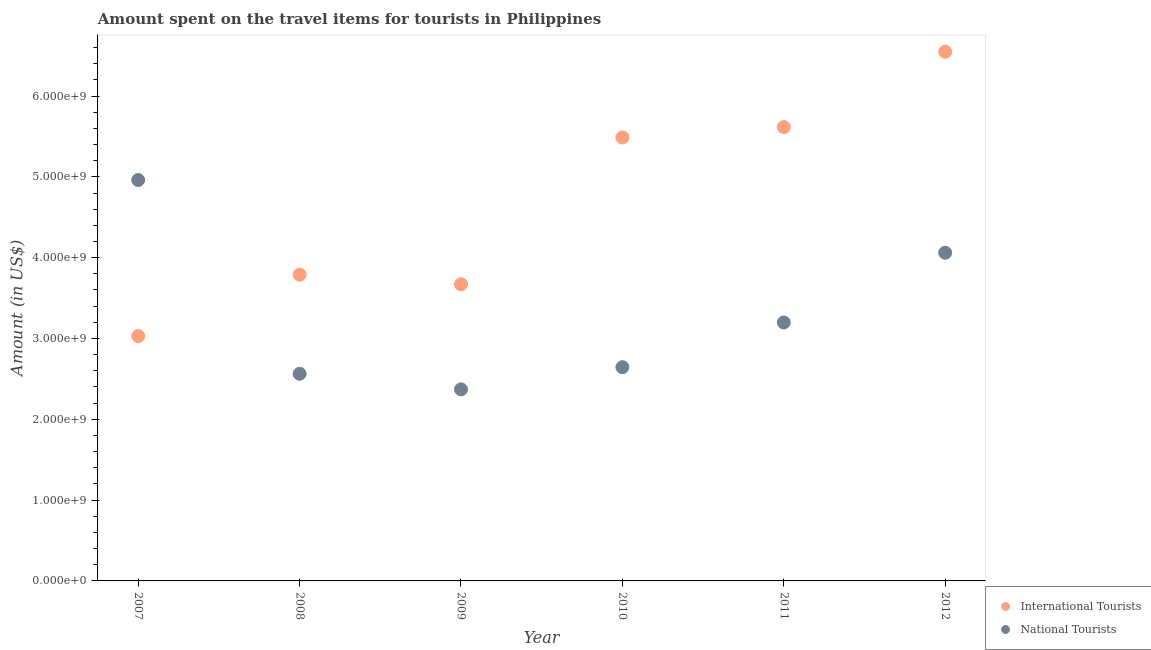What is the amount spent on travel items of national tourists in 2009?
Offer a terse response. 2.37e+09. Across all years, what is the maximum amount spent on travel items of international tourists?
Your response must be concise. 6.55e+09. Across all years, what is the minimum amount spent on travel items of international tourists?
Offer a very short reply. 3.03e+09. In which year was the amount spent on travel items of national tourists minimum?
Provide a short and direct response. 2009. What is the total amount spent on travel items of national tourists in the graph?
Give a very brief answer. 1.98e+1. What is the difference between the amount spent on travel items of national tourists in 2010 and that in 2012?
Your response must be concise. -1.42e+09. What is the difference between the amount spent on travel items of national tourists in 2010 and the amount spent on travel items of international tourists in 2009?
Make the answer very short. -1.03e+09. What is the average amount spent on travel items of national tourists per year?
Offer a very short reply. 3.30e+09. In the year 2011, what is the difference between the amount spent on travel items of national tourists and amount spent on travel items of international tourists?
Provide a succinct answer. -2.42e+09. What is the ratio of the amount spent on travel items of international tourists in 2011 to that in 2012?
Offer a terse response. 0.86. Is the amount spent on travel items of international tourists in 2010 less than that in 2012?
Offer a very short reply. Yes. What is the difference between the highest and the second highest amount spent on travel items of international tourists?
Your response must be concise. 9.32e+08. What is the difference between the highest and the lowest amount spent on travel items of national tourists?
Ensure brevity in your answer.  2.59e+09. In how many years, is the amount spent on travel items of national tourists greater than the average amount spent on travel items of national tourists taken over all years?
Your response must be concise. 2. Is the sum of the amount spent on travel items of national tourists in 2008 and 2010 greater than the maximum amount spent on travel items of international tourists across all years?
Provide a short and direct response. No. Does the amount spent on travel items of national tourists monotonically increase over the years?
Your answer should be compact. No. Is the amount spent on travel items of national tourists strictly greater than the amount spent on travel items of international tourists over the years?
Ensure brevity in your answer.  No. How many years are there in the graph?
Offer a very short reply. 6. Are the values on the major ticks of Y-axis written in scientific E-notation?
Your answer should be very brief. Yes. What is the title of the graph?
Provide a succinct answer. Amount spent on the travel items for tourists in Philippines. What is the Amount (in US$) in International Tourists in 2007?
Your response must be concise. 3.03e+09. What is the Amount (in US$) in National Tourists in 2007?
Give a very brief answer. 4.96e+09. What is the Amount (in US$) in International Tourists in 2008?
Give a very brief answer. 3.79e+09. What is the Amount (in US$) of National Tourists in 2008?
Your response must be concise. 2.56e+09. What is the Amount (in US$) in International Tourists in 2009?
Your answer should be compact. 3.67e+09. What is the Amount (in US$) in National Tourists in 2009?
Your response must be concise. 2.37e+09. What is the Amount (in US$) of International Tourists in 2010?
Your answer should be very brief. 5.49e+09. What is the Amount (in US$) of National Tourists in 2010?
Provide a short and direct response. 2.64e+09. What is the Amount (in US$) of International Tourists in 2011?
Ensure brevity in your answer.  5.62e+09. What is the Amount (in US$) of National Tourists in 2011?
Ensure brevity in your answer.  3.20e+09. What is the Amount (in US$) in International Tourists in 2012?
Provide a short and direct response. 6.55e+09. What is the Amount (in US$) in National Tourists in 2012?
Make the answer very short. 4.06e+09. Across all years, what is the maximum Amount (in US$) of International Tourists?
Your answer should be very brief. 6.55e+09. Across all years, what is the maximum Amount (in US$) of National Tourists?
Your response must be concise. 4.96e+09. Across all years, what is the minimum Amount (in US$) in International Tourists?
Ensure brevity in your answer.  3.03e+09. Across all years, what is the minimum Amount (in US$) of National Tourists?
Your response must be concise. 2.37e+09. What is the total Amount (in US$) of International Tourists in the graph?
Your answer should be compact. 2.81e+1. What is the total Amount (in US$) in National Tourists in the graph?
Make the answer very short. 1.98e+1. What is the difference between the Amount (in US$) in International Tourists in 2007 and that in 2008?
Offer a very short reply. -7.59e+08. What is the difference between the Amount (in US$) in National Tourists in 2007 and that in 2008?
Make the answer very short. 2.40e+09. What is the difference between the Amount (in US$) of International Tourists in 2007 and that in 2009?
Provide a succinct answer. -6.41e+08. What is the difference between the Amount (in US$) of National Tourists in 2007 and that in 2009?
Offer a terse response. 2.59e+09. What is the difference between the Amount (in US$) in International Tourists in 2007 and that in 2010?
Ensure brevity in your answer.  -2.46e+09. What is the difference between the Amount (in US$) in National Tourists in 2007 and that in 2010?
Your response must be concise. 2.32e+09. What is the difference between the Amount (in US$) in International Tourists in 2007 and that in 2011?
Keep it short and to the point. -2.59e+09. What is the difference between the Amount (in US$) in National Tourists in 2007 and that in 2011?
Your answer should be compact. 1.76e+09. What is the difference between the Amount (in US$) in International Tourists in 2007 and that in 2012?
Make the answer very short. -3.52e+09. What is the difference between the Amount (in US$) of National Tourists in 2007 and that in 2012?
Provide a short and direct response. 9.00e+08. What is the difference between the Amount (in US$) of International Tourists in 2008 and that in 2009?
Provide a short and direct response. 1.18e+08. What is the difference between the Amount (in US$) of National Tourists in 2008 and that in 2009?
Your answer should be compact. 1.93e+08. What is the difference between the Amount (in US$) in International Tourists in 2008 and that in 2010?
Offer a very short reply. -1.70e+09. What is the difference between the Amount (in US$) in National Tourists in 2008 and that in 2010?
Keep it short and to the point. -8.20e+07. What is the difference between the Amount (in US$) of International Tourists in 2008 and that in 2011?
Offer a very short reply. -1.83e+09. What is the difference between the Amount (in US$) in National Tourists in 2008 and that in 2011?
Ensure brevity in your answer.  -6.35e+08. What is the difference between the Amount (in US$) in International Tourists in 2008 and that in 2012?
Give a very brief answer. -2.76e+09. What is the difference between the Amount (in US$) in National Tourists in 2008 and that in 2012?
Provide a short and direct response. -1.50e+09. What is the difference between the Amount (in US$) of International Tourists in 2009 and that in 2010?
Keep it short and to the point. -1.82e+09. What is the difference between the Amount (in US$) in National Tourists in 2009 and that in 2010?
Offer a terse response. -2.75e+08. What is the difference between the Amount (in US$) in International Tourists in 2009 and that in 2011?
Ensure brevity in your answer.  -1.94e+09. What is the difference between the Amount (in US$) in National Tourists in 2009 and that in 2011?
Make the answer very short. -8.28e+08. What is the difference between the Amount (in US$) in International Tourists in 2009 and that in 2012?
Provide a succinct answer. -2.88e+09. What is the difference between the Amount (in US$) in National Tourists in 2009 and that in 2012?
Your answer should be very brief. -1.69e+09. What is the difference between the Amount (in US$) of International Tourists in 2010 and that in 2011?
Your response must be concise. -1.29e+08. What is the difference between the Amount (in US$) of National Tourists in 2010 and that in 2011?
Offer a terse response. -5.53e+08. What is the difference between the Amount (in US$) in International Tourists in 2010 and that in 2012?
Your answer should be very brief. -1.06e+09. What is the difference between the Amount (in US$) in National Tourists in 2010 and that in 2012?
Offer a terse response. -1.42e+09. What is the difference between the Amount (in US$) in International Tourists in 2011 and that in 2012?
Make the answer very short. -9.32e+08. What is the difference between the Amount (in US$) in National Tourists in 2011 and that in 2012?
Keep it short and to the point. -8.63e+08. What is the difference between the Amount (in US$) of International Tourists in 2007 and the Amount (in US$) of National Tourists in 2008?
Your answer should be compact. 4.67e+08. What is the difference between the Amount (in US$) of International Tourists in 2007 and the Amount (in US$) of National Tourists in 2009?
Your response must be concise. 6.60e+08. What is the difference between the Amount (in US$) of International Tourists in 2007 and the Amount (in US$) of National Tourists in 2010?
Your answer should be compact. 3.85e+08. What is the difference between the Amount (in US$) in International Tourists in 2007 and the Amount (in US$) in National Tourists in 2011?
Offer a terse response. -1.68e+08. What is the difference between the Amount (in US$) of International Tourists in 2007 and the Amount (in US$) of National Tourists in 2012?
Give a very brief answer. -1.03e+09. What is the difference between the Amount (in US$) in International Tourists in 2008 and the Amount (in US$) in National Tourists in 2009?
Your answer should be compact. 1.42e+09. What is the difference between the Amount (in US$) of International Tourists in 2008 and the Amount (in US$) of National Tourists in 2010?
Provide a succinct answer. 1.14e+09. What is the difference between the Amount (in US$) of International Tourists in 2008 and the Amount (in US$) of National Tourists in 2011?
Make the answer very short. 5.91e+08. What is the difference between the Amount (in US$) of International Tourists in 2008 and the Amount (in US$) of National Tourists in 2012?
Keep it short and to the point. -2.72e+08. What is the difference between the Amount (in US$) in International Tourists in 2009 and the Amount (in US$) in National Tourists in 2010?
Provide a succinct answer. 1.03e+09. What is the difference between the Amount (in US$) of International Tourists in 2009 and the Amount (in US$) of National Tourists in 2011?
Keep it short and to the point. 4.73e+08. What is the difference between the Amount (in US$) of International Tourists in 2009 and the Amount (in US$) of National Tourists in 2012?
Provide a succinct answer. -3.90e+08. What is the difference between the Amount (in US$) in International Tourists in 2010 and the Amount (in US$) in National Tourists in 2011?
Provide a short and direct response. 2.29e+09. What is the difference between the Amount (in US$) in International Tourists in 2010 and the Amount (in US$) in National Tourists in 2012?
Make the answer very short. 1.43e+09. What is the difference between the Amount (in US$) of International Tourists in 2011 and the Amount (in US$) of National Tourists in 2012?
Offer a very short reply. 1.56e+09. What is the average Amount (in US$) of International Tourists per year?
Ensure brevity in your answer.  4.69e+09. What is the average Amount (in US$) of National Tourists per year?
Your answer should be very brief. 3.30e+09. In the year 2007, what is the difference between the Amount (in US$) of International Tourists and Amount (in US$) of National Tourists?
Offer a very short reply. -1.93e+09. In the year 2008, what is the difference between the Amount (in US$) of International Tourists and Amount (in US$) of National Tourists?
Give a very brief answer. 1.23e+09. In the year 2009, what is the difference between the Amount (in US$) of International Tourists and Amount (in US$) of National Tourists?
Keep it short and to the point. 1.30e+09. In the year 2010, what is the difference between the Amount (in US$) in International Tourists and Amount (in US$) in National Tourists?
Provide a succinct answer. 2.84e+09. In the year 2011, what is the difference between the Amount (in US$) in International Tourists and Amount (in US$) in National Tourists?
Ensure brevity in your answer.  2.42e+09. In the year 2012, what is the difference between the Amount (in US$) of International Tourists and Amount (in US$) of National Tourists?
Your answer should be very brief. 2.49e+09. What is the ratio of the Amount (in US$) of International Tourists in 2007 to that in 2008?
Offer a terse response. 0.8. What is the ratio of the Amount (in US$) in National Tourists in 2007 to that in 2008?
Provide a succinct answer. 1.94. What is the ratio of the Amount (in US$) of International Tourists in 2007 to that in 2009?
Offer a terse response. 0.83. What is the ratio of the Amount (in US$) of National Tourists in 2007 to that in 2009?
Make the answer very short. 2.09. What is the ratio of the Amount (in US$) of International Tourists in 2007 to that in 2010?
Your answer should be compact. 0.55. What is the ratio of the Amount (in US$) of National Tourists in 2007 to that in 2010?
Give a very brief answer. 1.88. What is the ratio of the Amount (in US$) of International Tourists in 2007 to that in 2011?
Your response must be concise. 0.54. What is the ratio of the Amount (in US$) of National Tourists in 2007 to that in 2011?
Keep it short and to the point. 1.55. What is the ratio of the Amount (in US$) of International Tourists in 2007 to that in 2012?
Provide a short and direct response. 0.46. What is the ratio of the Amount (in US$) in National Tourists in 2007 to that in 2012?
Give a very brief answer. 1.22. What is the ratio of the Amount (in US$) of International Tourists in 2008 to that in 2009?
Your answer should be compact. 1.03. What is the ratio of the Amount (in US$) in National Tourists in 2008 to that in 2009?
Offer a terse response. 1.08. What is the ratio of the Amount (in US$) of International Tourists in 2008 to that in 2010?
Ensure brevity in your answer.  0.69. What is the ratio of the Amount (in US$) of National Tourists in 2008 to that in 2010?
Offer a very short reply. 0.97. What is the ratio of the Amount (in US$) in International Tourists in 2008 to that in 2011?
Your answer should be very brief. 0.67. What is the ratio of the Amount (in US$) in National Tourists in 2008 to that in 2011?
Offer a very short reply. 0.8. What is the ratio of the Amount (in US$) of International Tourists in 2008 to that in 2012?
Keep it short and to the point. 0.58. What is the ratio of the Amount (in US$) in National Tourists in 2008 to that in 2012?
Your answer should be compact. 0.63. What is the ratio of the Amount (in US$) in International Tourists in 2009 to that in 2010?
Give a very brief answer. 0.67. What is the ratio of the Amount (in US$) of National Tourists in 2009 to that in 2010?
Your answer should be very brief. 0.9. What is the ratio of the Amount (in US$) in International Tourists in 2009 to that in 2011?
Ensure brevity in your answer.  0.65. What is the ratio of the Amount (in US$) in National Tourists in 2009 to that in 2011?
Ensure brevity in your answer.  0.74. What is the ratio of the Amount (in US$) of International Tourists in 2009 to that in 2012?
Give a very brief answer. 0.56. What is the ratio of the Amount (in US$) of National Tourists in 2009 to that in 2012?
Keep it short and to the point. 0.58. What is the ratio of the Amount (in US$) of National Tourists in 2010 to that in 2011?
Your answer should be very brief. 0.83. What is the ratio of the Amount (in US$) in International Tourists in 2010 to that in 2012?
Ensure brevity in your answer.  0.84. What is the ratio of the Amount (in US$) of National Tourists in 2010 to that in 2012?
Provide a short and direct response. 0.65. What is the ratio of the Amount (in US$) in International Tourists in 2011 to that in 2012?
Provide a succinct answer. 0.86. What is the ratio of the Amount (in US$) of National Tourists in 2011 to that in 2012?
Your answer should be very brief. 0.79. What is the difference between the highest and the second highest Amount (in US$) of International Tourists?
Your answer should be compact. 9.32e+08. What is the difference between the highest and the second highest Amount (in US$) of National Tourists?
Your answer should be compact. 9.00e+08. What is the difference between the highest and the lowest Amount (in US$) of International Tourists?
Provide a short and direct response. 3.52e+09. What is the difference between the highest and the lowest Amount (in US$) in National Tourists?
Your answer should be very brief. 2.59e+09. 